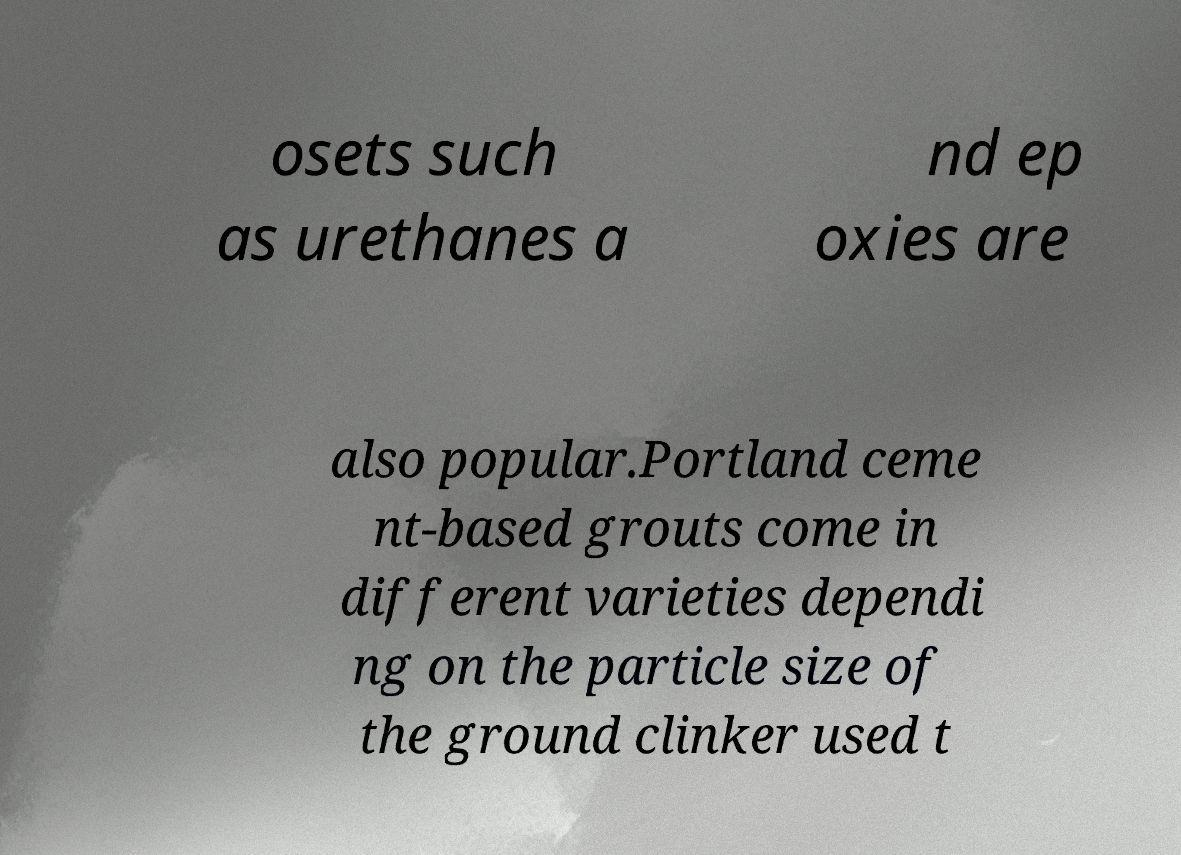Please read and relay the text visible in this image. What does it say? osets such as urethanes a nd ep oxies are also popular.Portland ceme nt-based grouts come in different varieties dependi ng on the particle size of the ground clinker used t 